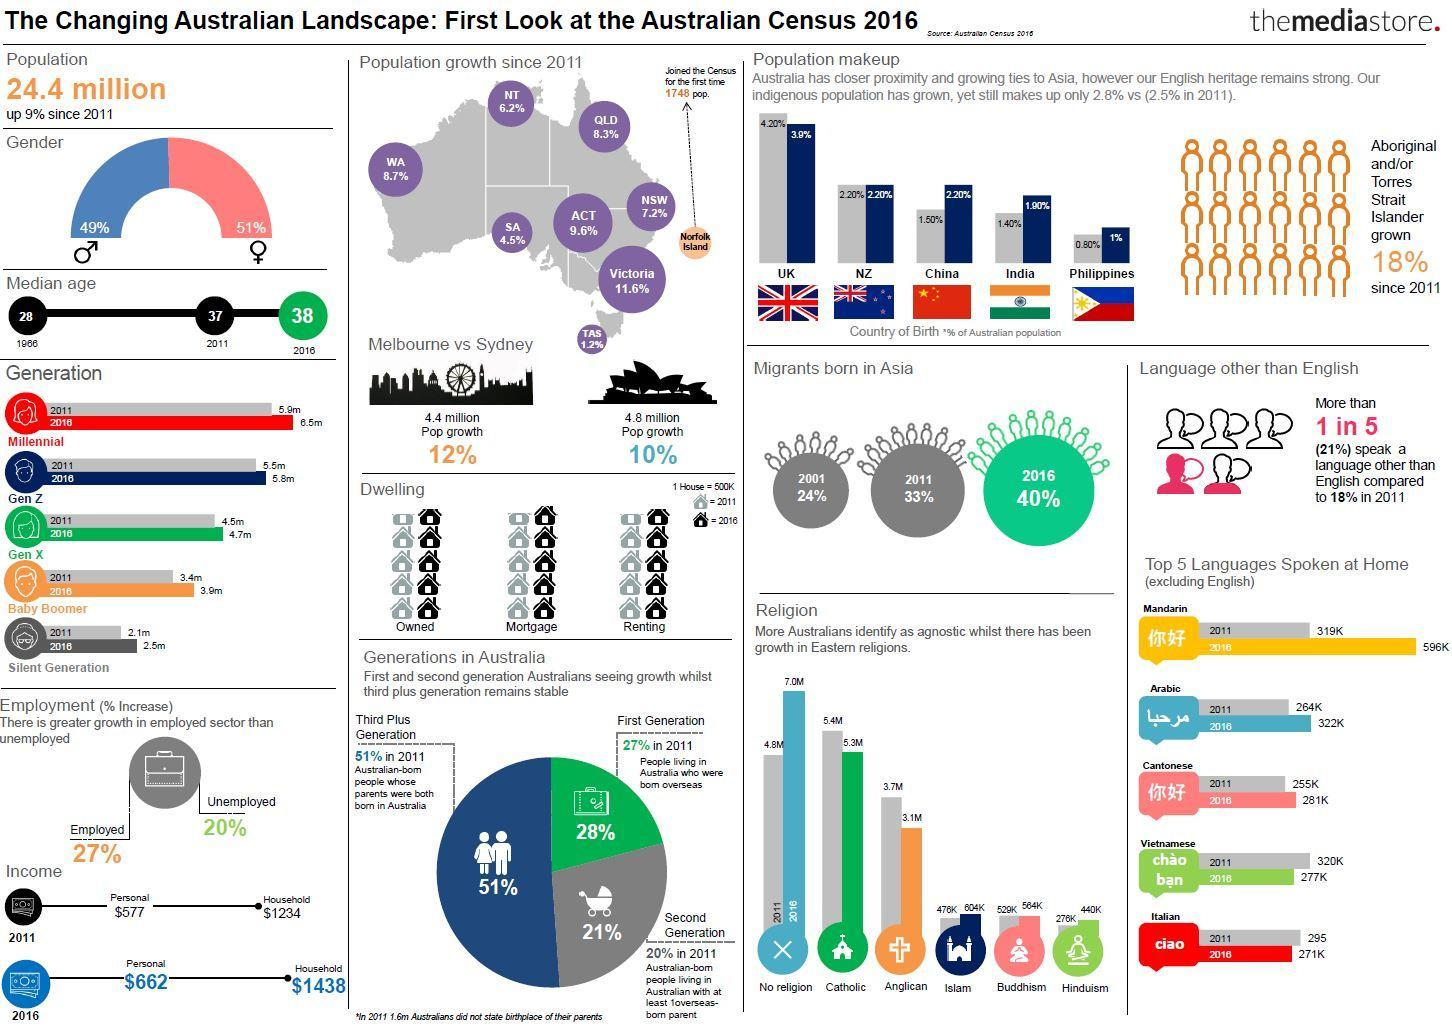What percentage of Australian population are Males?
Answer the question with a short phrase. 49% In which year highest no of Asian migrants reached Australia? 2016 What is the median age of Australians calculated in the year 2011? 37 What is the household Income of Australians in the year 2016? $1438 What is the population growth of Sydney? 10% What is the population of Sydney? 4.8 million What percentage of Australian population are Females? 51% What percentage of Australians are employed? 27% Into how many generations Australian people are divided? 5 What is the household Income of Australians in the year 2011? $1234 